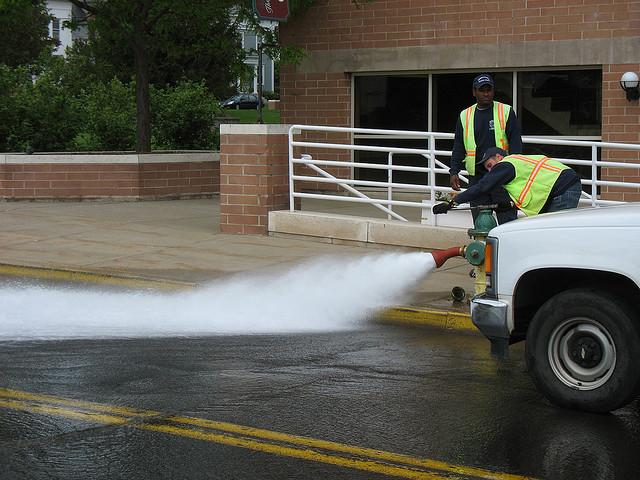How many people are in this picture?
Write a very short answer. 2. Is the road dry or wet?
Concise answer only. Wet. Is there a tire in this picture?
Keep it brief. Yes. 